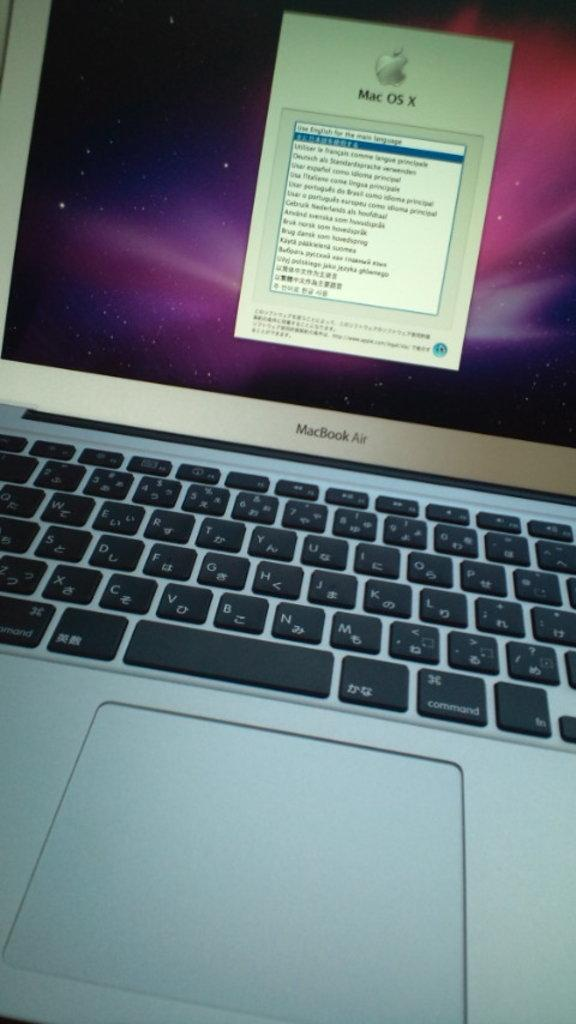<image>
Provide a brief description of the given image. a macbook air open and on a screen that says mac os x 